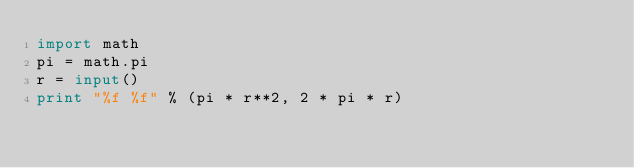<code> <loc_0><loc_0><loc_500><loc_500><_Python_>import math
pi = math.pi
r = input()
print "%f %f" % (pi * r**2, 2 * pi * r)</code> 